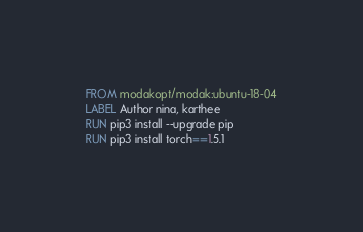Convert code to text. <code><loc_0><loc_0><loc_500><loc_500><_Dockerfile_>FROM modakopt/modak:ubuntu-18-04
LABEL Author nina, karthee
RUN pip3 install --upgrade pip
RUN pip3 install torch==1.5.1
</code> 